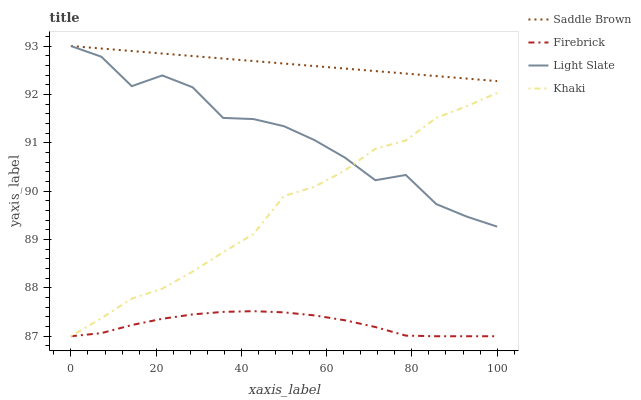Does Firebrick have the minimum area under the curve?
Answer yes or no. Yes. Does Saddle Brown have the maximum area under the curve?
Answer yes or no. Yes. Does Khaki have the minimum area under the curve?
Answer yes or no. No. Does Khaki have the maximum area under the curve?
Answer yes or no. No. Is Saddle Brown the smoothest?
Answer yes or no. Yes. Is Light Slate the roughest?
Answer yes or no. Yes. Is Firebrick the smoothest?
Answer yes or no. No. Is Firebrick the roughest?
Answer yes or no. No. Does Firebrick have the lowest value?
Answer yes or no. Yes. Does Saddle Brown have the lowest value?
Answer yes or no. No. Does Saddle Brown have the highest value?
Answer yes or no. Yes. Does Khaki have the highest value?
Answer yes or no. No. Is Khaki less than Saddle Brown?
Answer yes or no. Yes. Is Saddle Brown greater than Khaki?
Answer yes or no. Yes. Does Firebrick intersect Khaki?
Answer yes or no. Yes. Is Firebrick less than Khaki?
Answer yes or no. No. Is Firebrick greater than Khaki?
Answer yes or no. No. Does Khaki intersect Saddle Brown?
Answer yes or no. No. 